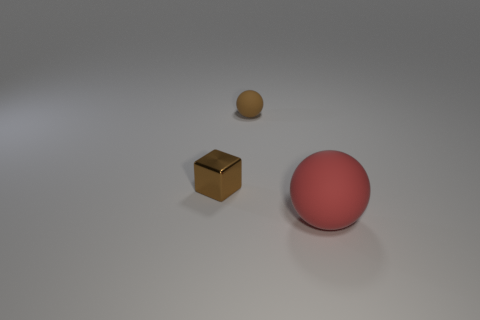Can you guess the approximate size of the objects relative to each other? Judging from the perspective, the red sphere appears to be the largest object, perhaps comparable to a small ball one might hold in their hand. The brown cube is smaller, possibly like a standard dice or a bit larger. The smallest object, the beige sphere, seems to be about half the height of the cube, suggesting it could be as small as a marble. 